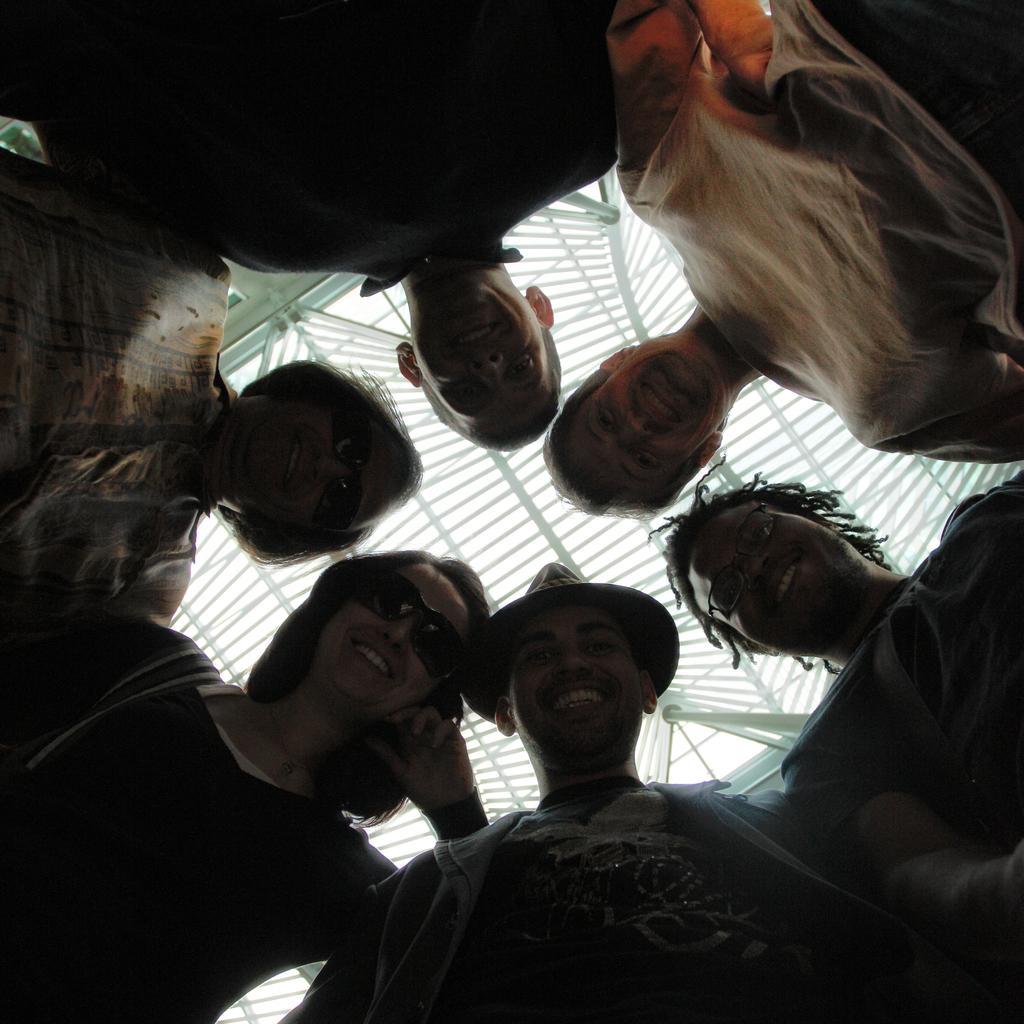How would you summarize this image in a sentence or two? In this picture we can see some people standing here, these two women wore goggles, we can see ceiling at the top of the picture, this man wore a cap. 